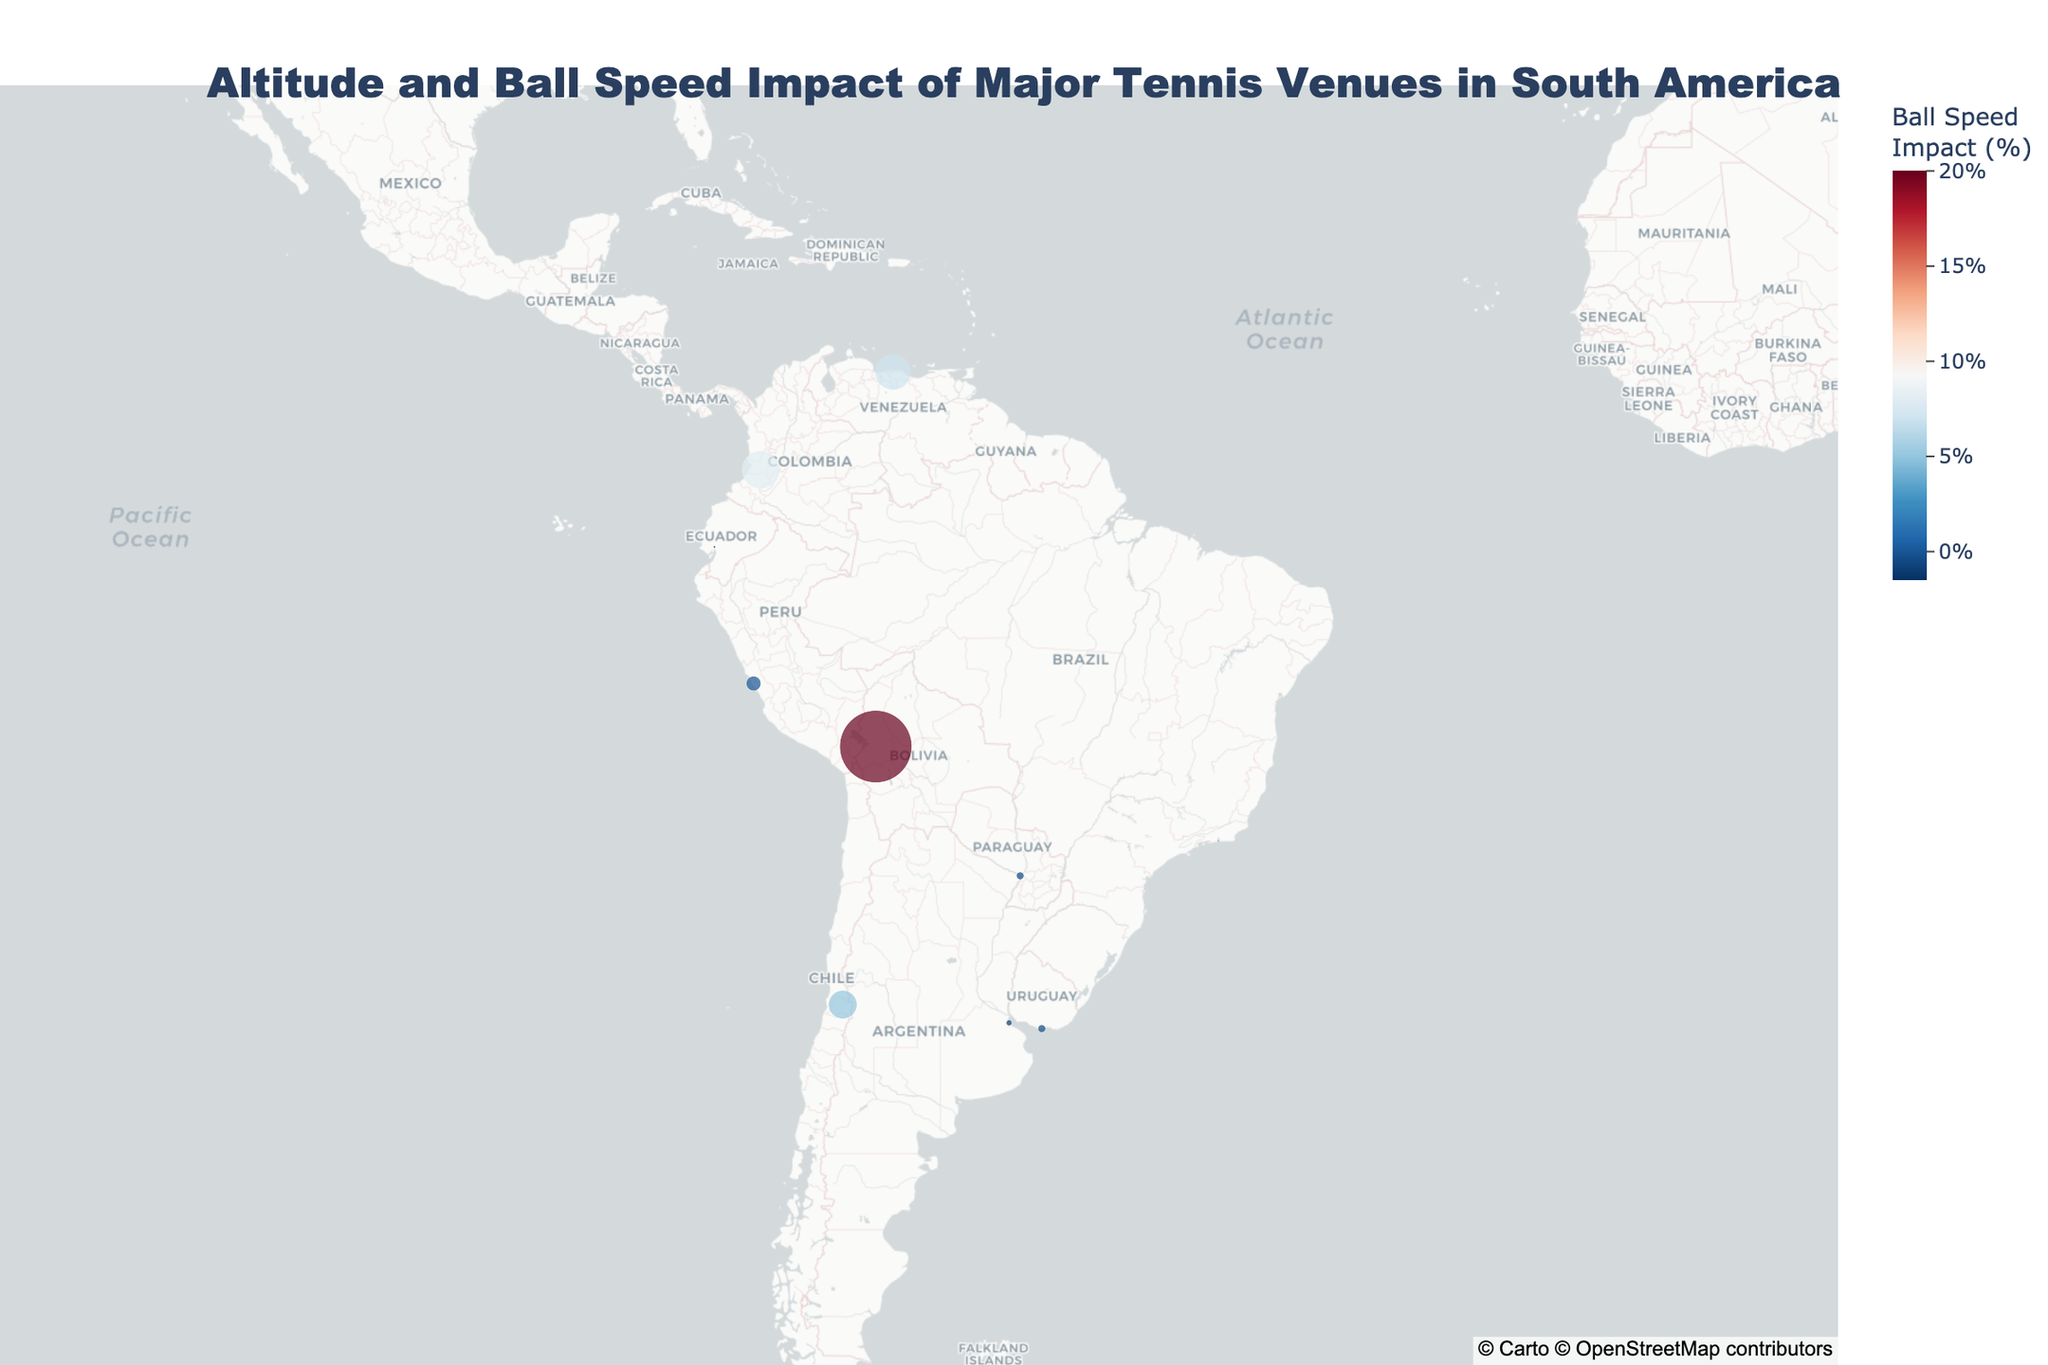What is the venue with the highest altitude? The venue with the highest altitude can be determined by looking at the dot size on the geographic plot and identifying the largest one. The largest dot corresponds to La Paz Tennis Club in La Paz, Bolivia, with an altitude of 3640 meters.
Answer: La Paz Tennis Club, Bolivia Which city has the most significant positive impact on ball speed? To identify the city with the most significant positive impact on ball speed, refer to the dot with the warmest color (reddish tones) and the highest percentage value. La Paz, Bolivia has a ball speed impact of 20%.
Answer: La Paz, Bolivia What is the ball speed impact at Club Lawn Tennis de la Exposición in Lima, Peru? Hovering over the dot representing Lima, Peru, shows that the impact on ball speed is 0%.
Answer: 0% Compare the ball speed impact between venues in Ecuador and Uruguay. Hover over the dots representing Guayaquil, Ecuador, and Montevideo, Uruguay. The ball speed impact in Guayaquil is -1.5%, while in Montevideo, it is -0.5%. Thus, the impact is greater in Ecuador.
Answer: Guayaquil: -1.5%, Montevideo: -0.5% How does the altitude of Santiago, Chile compare to Bogota, Colombia? Hover over the dots for Santiago, Chile, and Bogota, Colombia to note their altitudes. Santiago has an altitude of 570 meters, while Bogota has an altitude of 1018 meters. Therefore, Bogota is higher in altitude than Santiago.
Answer: Santiago: 570m, Bogota: 1018m Which venues have a negative impact on ball speed? By looking at the cooler colors (blueish tones) and negative percentage values, the venues are Buenos Aires, Argentina (-1%), Rio de Janeiro, Brazil (-1.5%), Guayaquil, Ecuador (-1.5%), and Montevideo, Uruguay (-0.5%).
Answer: Buenos Aires, Rio de Janeiro, Guayaquil, Montevideo How many venues are at an altitude higher than 500 meters? Identify and count the dots with altitudes higher than 500 meters. These venues are Club Campestre de Cali (1018m), Club Deportivo Universidad Católica (570m), La Paz Tennis Club (3640m), and Caracas Country Club (917m). Thus there are four venues.
Answer: Four What is the average altitude of the venues in Lima, Buenos Aires, and Rio de Janeiro? Sum their altitudes (154m + 25m + 2m = 181m) and divide by the number of venues (3). 181/3 = 60.33 meters.
Answer: 60.33m Which country has the venue with the lowest altitude? Identify the venue dot with the smallest size for lowest altitude (2m), which is in Rio de Janeiro, Brazil.
Answer: Brazil 